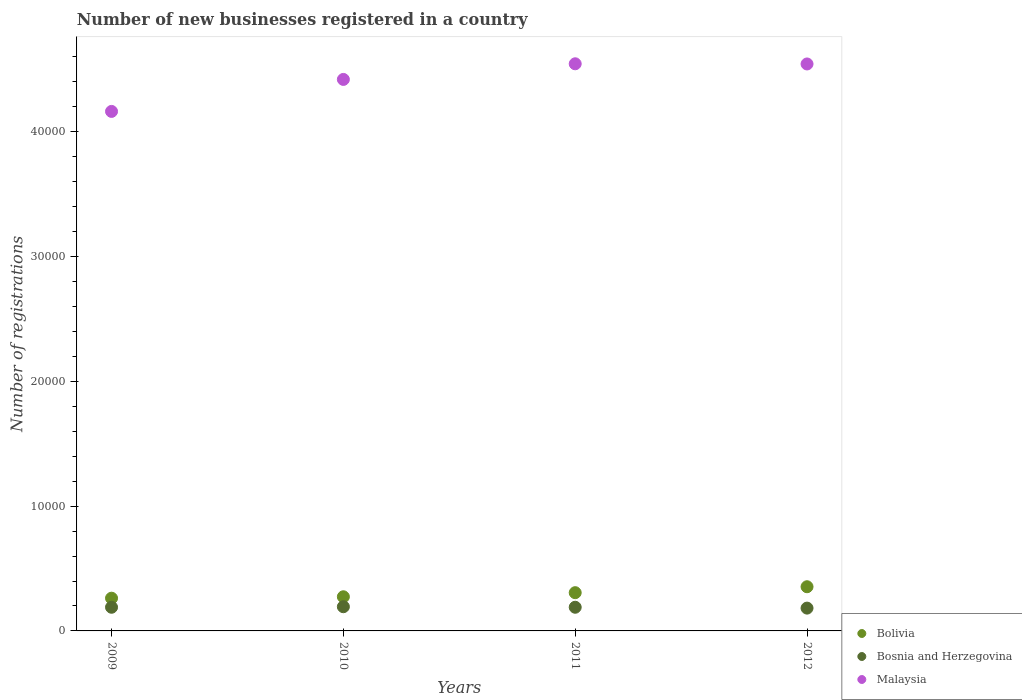Is the number of dotlines equal to the number of legend labels?
Ensure brevity in your answer.  Yes. What is the number of new businesses registered in Malaysia in 2009?
Offer a terse response. 4.16e+04. Across all years, what is the maximum number of new businesses registered in Malaysia?
Provide a succinct answer. 4.55e+04. Across all years, what is the minimum number of new businesses registered in Malaysia?
Provide a short and direct response. 4.16e+04. In which year was the number of new businesses registered in Bosnia and Herzegovina minimum?
Provide a short and direct response. 2012. What is the total number of new businesses registered in Malaysia in the graph?
Offer a terse response. 1.77e+05. What is the difference between the number of new businesses registered in Bolivia in 2010 and that in 2011?
Ensure brevity in your answer.  -328. What is the difference between the number of new businesses registered in Bolivia in 2011 and the number of new businesses registered in Bosnia and Herzegovina in 2009?
Offer a very short reply. 1169. What is the average number of new businesses registered in Bolivia per year?
Your response must be concise. 2991.5. In the year 2012, what is the difference between the number of new businesses registered in Malaysia and number of new businesses registered in Bolivia?
Give a very brief answer. 4.19e+04. What is the ratio of the number of new businesses registered in Bosnia and Herzegovina in 2010 to that in 2011?
Provide a succinct answer. 1.02. Is the number of new businesses registered in Bosnia and Herzegovina in 2009 less than that in 2011?
Provide a succinct answer. Yes. Is the difference between the number of new businesses registered in Malaysia in 2009 and 2012 greater than the difference between the number of new businesses registered in Bolivia in 2009 and 2012?
Your answer should be compact. No. What is the difference between the highest and the second highest number of new businesses registered in Malaysia?
Provide a short and direct response. 14. What is the difference between the highest and the lowest number of new businesses registered in Malaysia?
Your response must be concise. 3817. Is it the case that in every year, the sum of the number of new businesses registered in Bolivia and number of new businesses registered in Bosnia and Herzegovina  is greater than the number of new businesses registered in Malaysia?
Ensure brevity in your answer.  No. Does the number of new businesses registered in Bolivia monotonically increase over the years?
Your answer should be compact. Yes. What is the difference between two consecutive major ticks on the Y-axis?
Provide a succinct answer. 10000. How many legend labels are there?
Give a very brief answer. 3. What is the title of the graph?
Make the answer very short. Number of new businesses registered in a country. Does "Lebanon" appear as one of the legend labels in the graph?
Keep it short and to the point. No. What is the label or title of the Y-axis?
Your answer should be very brief. Number of registrations. What is the Number of registrations in Bolivia in 2009?
Provide a succinct answer. 2623. What is the Number of registrations of Bosnia and Herzegovina in 2009?
Ensure brevity in your answer.  1896. What is the Number of registrations in Malaysia in 2009?
Offer a terse response. 4.16e+04. What is the Number of registrations of Bolivia in 2010?
Your answer should be compact. 2737. What is the Number of registrations of Bosnia and Herzegovina in 2010?
Your response must be concise. 1939. What is the Number of registrations of Malaysia in 2010?
Provide a succinct answer. 4.42e+04. What is the Number of registrations in Bolivia in 2011?
Your answer should be compact. 3065. What is the Number of registrations in Bosnia and Herzegovina in 2011?
Offer a terse response. 1897. What is the Number of registrations in Malaysia in 2011?
Make the answer very short. 4.55e+04. What is the Number of registrations in Bolivia in 2012?
Provide a succinct answer. 3541. What is the Number of registrations in Bosnia and Herzegovina in 2012?
Make the answer very short. 1828. What is the Number of registrations in Malaysia in 2012?
Ensure brevity in your answer.  4.54e+04. Across all years, what is the maximum Number of registrations of Bolivia?
Offer a terse response. 3541. Across all years, what is the maximum Number of registrations in Bosnia and Herzegovina?
Offer a terse response. 1939. Across all years, what is the maximum Number of registrations of Malaysia?
Your answer should be very brief. 4.55e+04. Across all years, what is the minimum Number of registrations of Bolivia?
Provide a succinct answer. 2623. Across all years, what is the minimum Number of registrations in Bosnia and Herzegovina?
Your answer should be compact. 1828. Across all years, what is the minimum Number of registrations of Malaysia?
Your answer should be compact. 4.16e+04. What is the total Number of registrations of Bolivia in the graph?
Offer a very short reply. 1.20e+04. What is the total Number of registrations in Bosnia and Herzegovina in the graph?
Your response must be concise. 7560. What is the total Number of registrations of Malaysia in the graph?
Your answer should be compact. 1.77e+05. What is the difference between the Number of registrations of Bolivia in 2009 and that in 2010?
Offer a terse response. -114. What is the difference between the Number of registrations of Bosnia and Herzegovina in 2009 and that in 2010?
Provide a succinct answer. -43. What is the difference between the Number of registrations in Malaysia in 2009 and that in 2010?
Your answer should be compact. -2564. What is the difference between the Number of registrations of Bolivia in 2009 and that in 2011?
Your answer should be compact. -442. What is the difference between the Number of registrations in Bosnia and Herzegovina in 2009 and that in 2011?
Your response must be concise. -1. What is the difference between the Number of registrations of Malaysia in 2009 and that in 2011?
Keep it short and to the point. -3817. What is the difference between the Number of registrations of Bolivia in 2009 and that in 2012?
Provide a succinct answer. -918. What is the difference between the Number of registrations in Malaysia in 2009 and that in 2012?
Offer a terse response. -3803. What is the difference between the Number of registrations of Bolivia in 2010 and that in 2011?
Offer a very short reply. -328. What is the difference between the Number of registrations in Malaysia in 2010 and that in 2011?
Keep it short and to the point. -1253. What is the difference between the Number of registrations of Bolivia in 2010 and that in 2012?
Your answer should be very brief. -804. What is the difference between the Number of registrations of Bosnia and Herzegovina in 2010 and that in 2012?
Ensure brevity in your answer.  111. What is the difference between the Number of registrations of Malaysia in 2010 and that in 2012?
Offer a terse response. -1239. What is the difference between the Number of registrations in Bolivia in 2011 and that in 2012?
Provide a succinct answer. -476. What is the difference between the Number of registrations in Bolivia in 2009 and the Number of registrations in Bosnia and Herzegovina in 2010?
Keep it short and to the point. 684. What is the difference between the Number of registrations in Bolivia in 2009 and the Number of registrations in Malaysia in 2010?
Offer a very short reply. -4.16e+04. What is the difference between the Number of registrations in Bosnia and Herzegovina in 2009 and the Number of registrations in Malaysia in 2010?
Make the answer very short. -4.23e+04. What is the difference between the Number of registrations in Bolivia in 2009 and the Number of registrations in Bosnia and Herzegovina in 2011?
Offer a terse response. 726. What is the difference between the Number of registrations of Bolivia in 2009 and the Number of registrations of Malaysia in 2011?
Ensure brevity in your answer.  -4.28e+04. What is the difference between the Number of registrations in Bosnia and Herzegovina in 2009 and the Number of registrations in Malaysia in 2011?
Give a very brief answer. -4.36e+04. What is the difference between the Number of registrations of Bolivia in 2009 and the Number of registrations of Bosnia and Herzegovina in 2012?
Your response must be concise. 795. What is the difference between the Number of registrations of Bolivia in 2009 and the Number of registrations of Malaysia in 2012?
Give a very brief answer. -4.28e+04. What is the difference between the Number of registrations in Bosnia and Herzegovina in 2009 and the Number of registrations in Malaysia in 2012?
Offer a very short reply. -4.35e+04. What is the difference between the Number of registrations of Bolivia in 2010 and the Number of registrations of Bosnia and Herzegovina in 2011?
Your answer should be very brief. 840. What is the difference between the Number of registrations in Bolivia in 2010 and the Number of registrations in Malaysia in 2011?
Your response must be concise. -4.27e+04. What is the difference between the Number of registrations in Bosnia and Herzegovina in 2010 and the Number of registrations in Malaysia in 2011?
Your answer should be compact. -4.35e+04. What is the difference between the Number of registrations of Bolivia in 2010 and the Number of registrations of Bosnia and Herzegovina in 2012?
Make the answer very short. 909. What is the difference between the Number of registrations in Bolivia in 2010 and the Number of registrations in Malaysia in 2012?
Give a very brief answer. -4.27e+04. What is the difference between the Number of registrations of Bosnia and Herzegovina in 2010 and the Number of registrations of Malaysia in 2012?
Your response must be concise. -4.35e+04. What is the difference between the Number of registrations of Bolivia in 2011 and the Number of registrations of Bosnia and Herzegovina in 2012?
Your answer should be very brief. 1237. What is the difference between the Number of registrations of Bolivia in 2011 and the Number of registrations of Malaysia in 2012?
Provide a succinct answer. -4.24e+04. What is the difference between the Number of registrations of Bosnia and Herzegovina in 2011 and the Number of registrations of Malaysia in 2012?
Make the answer very short. -4.35e+04. What is the average Number of registrations in Bolivia per year?
Give a very brief answer. 2991.5. What is the average Number of registrations of Bosnia and Herzegovina per year?
Your answer should be very brief. 1890. What is the average Number of registrations in Malaysia per year?
Provide a succinct answer. 4.42e+04. In the year 2009, what is the difference between the Number of registrations of Bolivia and Number of registrations of Bosnia and Herzegovina?
Give a very brief answer. 727. In the year 2009, what is the difference between the Number of registrations in Bolivia and Number of registrations in Malaysia?
Offer a terse response. -3.90e+04. In the year 2009, what is the difference between the Number of registrations of Bosnia and Herzegovina and Number of registrations of Malaysia?
Your answer should be compact. -3.97e+04. In the year 2010, what is the difference between the Number of registrations in Bolivia and Number of registrations in Bosnia and Herzegovina?
Your answer should be compact. 798. In the year 2010, what is the difference between the Number of registrations of Bolivia and Number of registrations of Malaysia?
Offer a terse response. -4.15e+04. In the year 2010, what is the difference between the Number of registrations of Bosnia and Herzegovina and Number of registrations of Malaysia?
Your answer should be compact. -4.23e+04. In the year 2011, what is the difference between the Number of registrations of Bolivia and Number of registrations of Bosnia and Herzegovina?
Offer a very short reply. 1168. In the year 2011, what is the difference between the Number of registrations in Bolivia and Number of registrations in Malaysia?
Give a very brief answer. -4.24e+04. In the year 2011, what is the difference between the Number of registrations in Bosnia and Herzegovina and Number of registrations in Malaysia?
Your answer should be compact. -4.36e+04. In the year 2012, what is the difference between the Number of registrations of Bolivia and Number of registrations of Bosnia and Herzegovina?
Ensure brevity in your answer.  1713. In the year 2012, what is the difference between the Number of registrations in Bolivia and Number of registrations in Malaysia?
Provide a succinct answer. -4.19e+04. In the year 2012, what is the difference between the Number of registrations of Bosnia and Herzegovina and Number of registrations of Malaysia?
Your answer should be very brief. -4.36e+04. What is the ratio of the Number of registrations in Bolivia in 2009 to that in 2010?
Ensure brevity in your answer.  0.96. What is the ratio of the Number of registrations in Bosnia and Herzegovina in 2009 to that in 2010?
Make the answer very short. 0.98. What is the ratio of the Number of registrations of Malaysia in 2009 to that in 2010?
Ensure brevity in your answer.  0.94. What is the ratio of the Number of registrations of Bolivia in 2009 to that in 2011?
Provide a succinct answer. 0.86. What is the ratio of the Number of registrations of Malaysia in 2009 to that in 2011?
Provide a succinct answer. 0.92. What is the ratio of the Number of registrations in Bolivia in 2009 to that in 2012?
Offer a very short reply. 0.74. What is the ratio of the Number of registrations in Bosnia and Herzegovina in 2009 to that in 2012?
Ensure brevity in your answer.  1.04. What is the ratio of the Number of registrations in Malaysia in 2009 to that in 2012?
Offer a very short reply. 0.92. What is the ratio of the Number of registrations of Bolivia in 2010 to that in 2011?
Keep it short and to the point. 0.89. What is the ratio of the Number of registrations in Bosnia and Herzegovina in 2010 to that in 2011?
Provide a short and direct response. 1.02. What is the ratio of the Number of registrations of Malaysia in 2010 to that in 2011?
Your answer should be very brief. 0.97. What is the ratio of the Number of registrations in Bolivia in 2010 to that in 2012?
Make the answer very short. 0.77. What is the ratio of the Number of registrations in Bosnia and Herzegovina in 2010 to that in 2012?
Your answer should be very brief. 1.06. What is the ratio of the Number of registrations in Malaysia in 2010 to that in 2012?
Keep it short and to the point. 0.97. What is the ratio of the Number of registrations of Bolivia in 2011 to that in 2012?
Ensure brevity in your answer.  0.87. What is the ratio of the Number of registrations in Bosnia and Herzegovina in 2011 to that in 2012?
Offer a terse response. 1.04. What is the ratio of the Number of registrations in Malaysia in 2011 to that in 2012?
Your response must be concise. 1. What is the difference between the highest and the second highest Number of registrations of Bolivia?
Offer a terse response. 476. What is the difference between the highest and the second highest Number of registrations of Bosnia and Herzegovina?
Keep it short and to the point. 42. What is the difference between the highest and the second highest Number of registrations in Malaysia?
Provide a succinct answer. 14. What is the difference between the highest and the lowest Number of registrations in Bolivia?
Provide a succinct answer. 918. What is the difference between the highest and the lowest Number of registrations in Bosnia and Herzegovina?
Ensure brevity in your answer.  111. What is the difference between the highest and the lowest Number of registrations in Malaysia?
Your answer should be compact. 3817. 